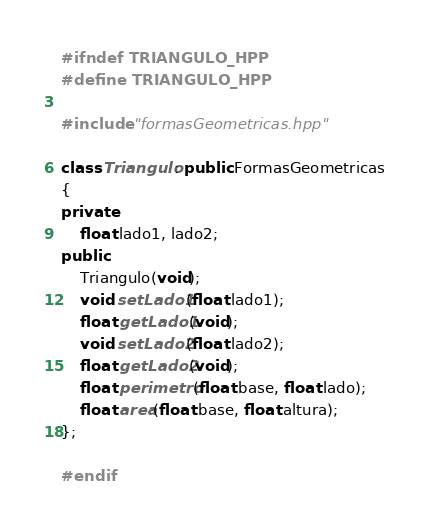Convert code to text. <code><loc_0><loc_0><loc_500><loc_500><_C++_>#ifndef TRIANGULO_HPP
#define TRIANGULO_HPP

#include "formasGeometricas.hpp"

class Triangulo: public FormasGeometricas
{
private:
    float lado1, lado2;
public:
    Triangulo(void);
    void setLado1(float lado1);
    float getLado1(void);
    void setLado2(float lado2);
    float getLado2(void);
    float perimetro(float base, float lado);
    float area(float base, float altura);
};

#endif
</code> 